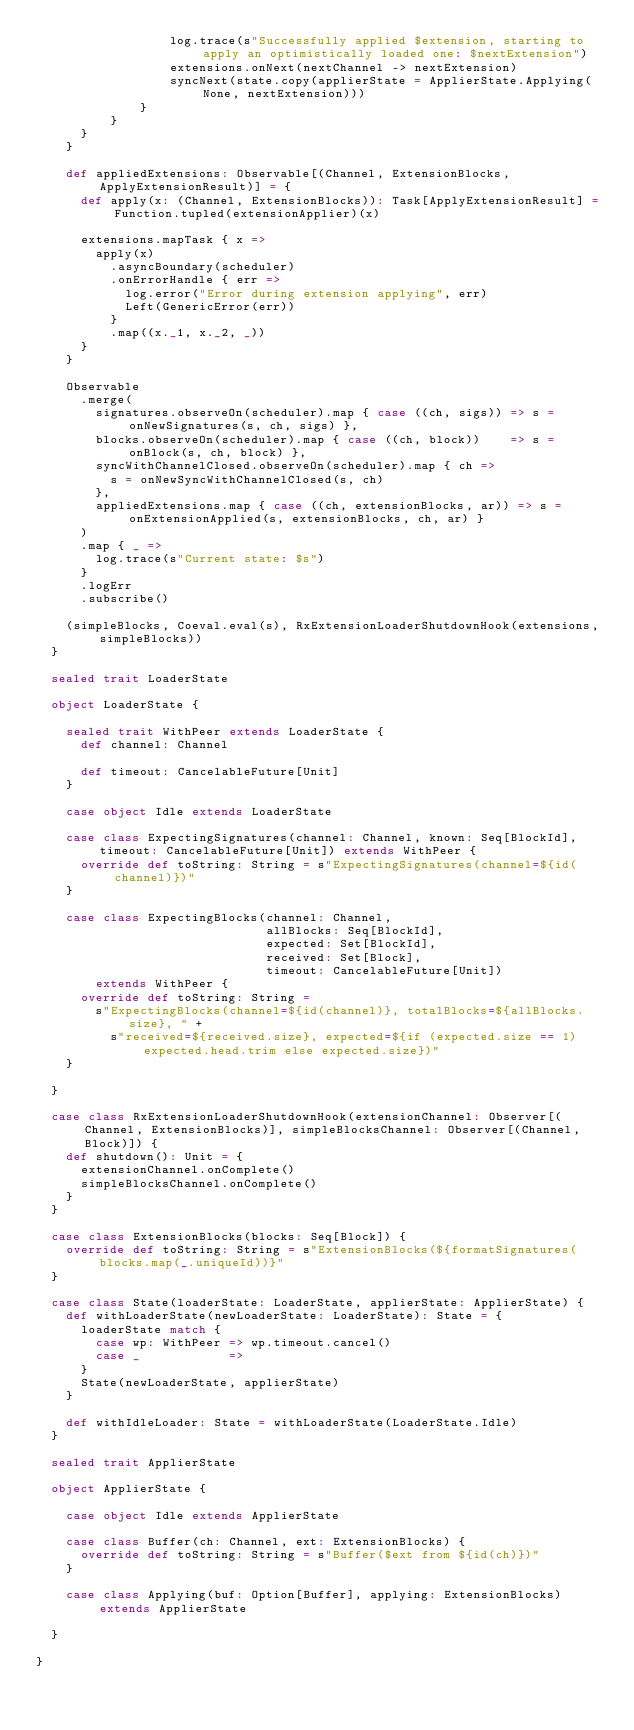<code> <loc_0><loc_0><loc_500><loc_500><_Scala_>                  log.trace(s"Successfully applied $extension, starting to apply an optimistically loaded one: $nextExtension")
                  extensions.onNext(nextChannel -> nextExtension)
                  syncNext(state.copy(applierState = ApplierState.Applying(None, nextExtension)))
              }
          }
      }
    }

    def appliedExtensions: Observable[(Channel, ExtensionBlocks, ApplyExtensionResult)] = {
      def apply(x: (Channel, ExtensionBlocks)): Task[ApplyExtensionResult] = Function.tupled(extensionApplier)(x)

      extensions.mapTask { x =>
        apply(x)
          .asyncBoundary(scheduler)
          .onErrorHandle { err =>
            log.error("Error during extension applying", err)
            Left(GenericError(err))
          }
          .map((x._1, x._2, _))
      }
    }

    Observable
      .merge(
        signatures.observeOn(scheduler).map { case ((ch, sigs)) => s = onNewSignatures(s, ch, sigs) },
        blocks.observeOn(scheduler).map { case ((ch, block))    => s = onBlock(s, ch, block) },
        syncWithChannelClosed.observeOn(scheduler).map { ch =>
          s = onNewSyncWithChannelClosed(s, ch)
        },
        appliedExtensions.map { case ((ch, extensionBlocks, ar)) => s = onExtensionApplied(s, extensionBlocks, ch, ar) }
      )
      .map { _ =>
        log.trace(s"Current state: $s")
      }
      .logErr
      .subscribe()

    (simpleBlocks, Coeval.eval(s), RxExtensionLoaderShutdownHook(extensions, simpleBlocks))
  }

  sealed trait LoaderState

  object LoaderState {

    sealed trait WithPeer extends LoaderState {
      def channel: Channel

      def timeout: CancelableFuture[Unit]
    }

    case object Idle extends LoaderState

    case class ExpectingSignatures(channel: Channel, known: Seq[BlockId], timeout: CancelableFuture[Unit]) extends WithPeer {
      override def toString: String = s"ExpectingSignatures(channel=${id(channel)})"
    }

    case class ExpectingBlocks(channel: Channel,
                               allBlocks: Seq[BlockId],
                               expected: Set[BlockId],
                               received: Set[Block],
                               timeout: CancelableFuture[Unit])
        extends WithPeer {
      override def toString: String =
        s"ExpectingBlocks(channel=${id(channel)}, totalBlocks=${allBlocks.size}, " +
          s"received=${received.size}, expected=${if (expected.size == 1) expected.head.trim else expected.size})"
    }

  }

  case class RxExtensionLoaderShutdownHook(extensionChannel: Observer[(Channel, ExtensionBlocks)], simpleBlocksChannel: Observer[(Channel, Block)]) {
    def shutdown(): Unit = {
      extensionChannel.onComplete()
      simpleBlocksChannel.onComplete()
    }
  }

  case class ExtensionBlocks(blocks: Seq[Block]) {
    override def toString: String = s"ExtensionBlocks(${formatSignatures(blocks.map(_.uniqueId))}"
  }

  case class State(loaderState: LoaderState, applierState: ApplierState) {
    def withLoaderState(newLoaderState: LoaderState): State = {
      loaderState match {
        case wp: WithPeer => wp.timeout.cancel()
        case _            =>
      }
      State(newLoaderState, applierState)
    }

    def withIdleLoader: State = withLoaderState(LoaderState.Idle)
  }

  sealed trait ApplierState

  object ApplierState {

    case object Idle extends ApplierState

    case class Buffer(ch: Channel, ext: ExtensionBlocks) {
      override def toString: String = s"Buffer($ext from ${id(ch)})"
    }

    case class Applying(buf: Option[Buffer], applying: ExtensionBlocks) extends ApplierState

  }

}
</code> 